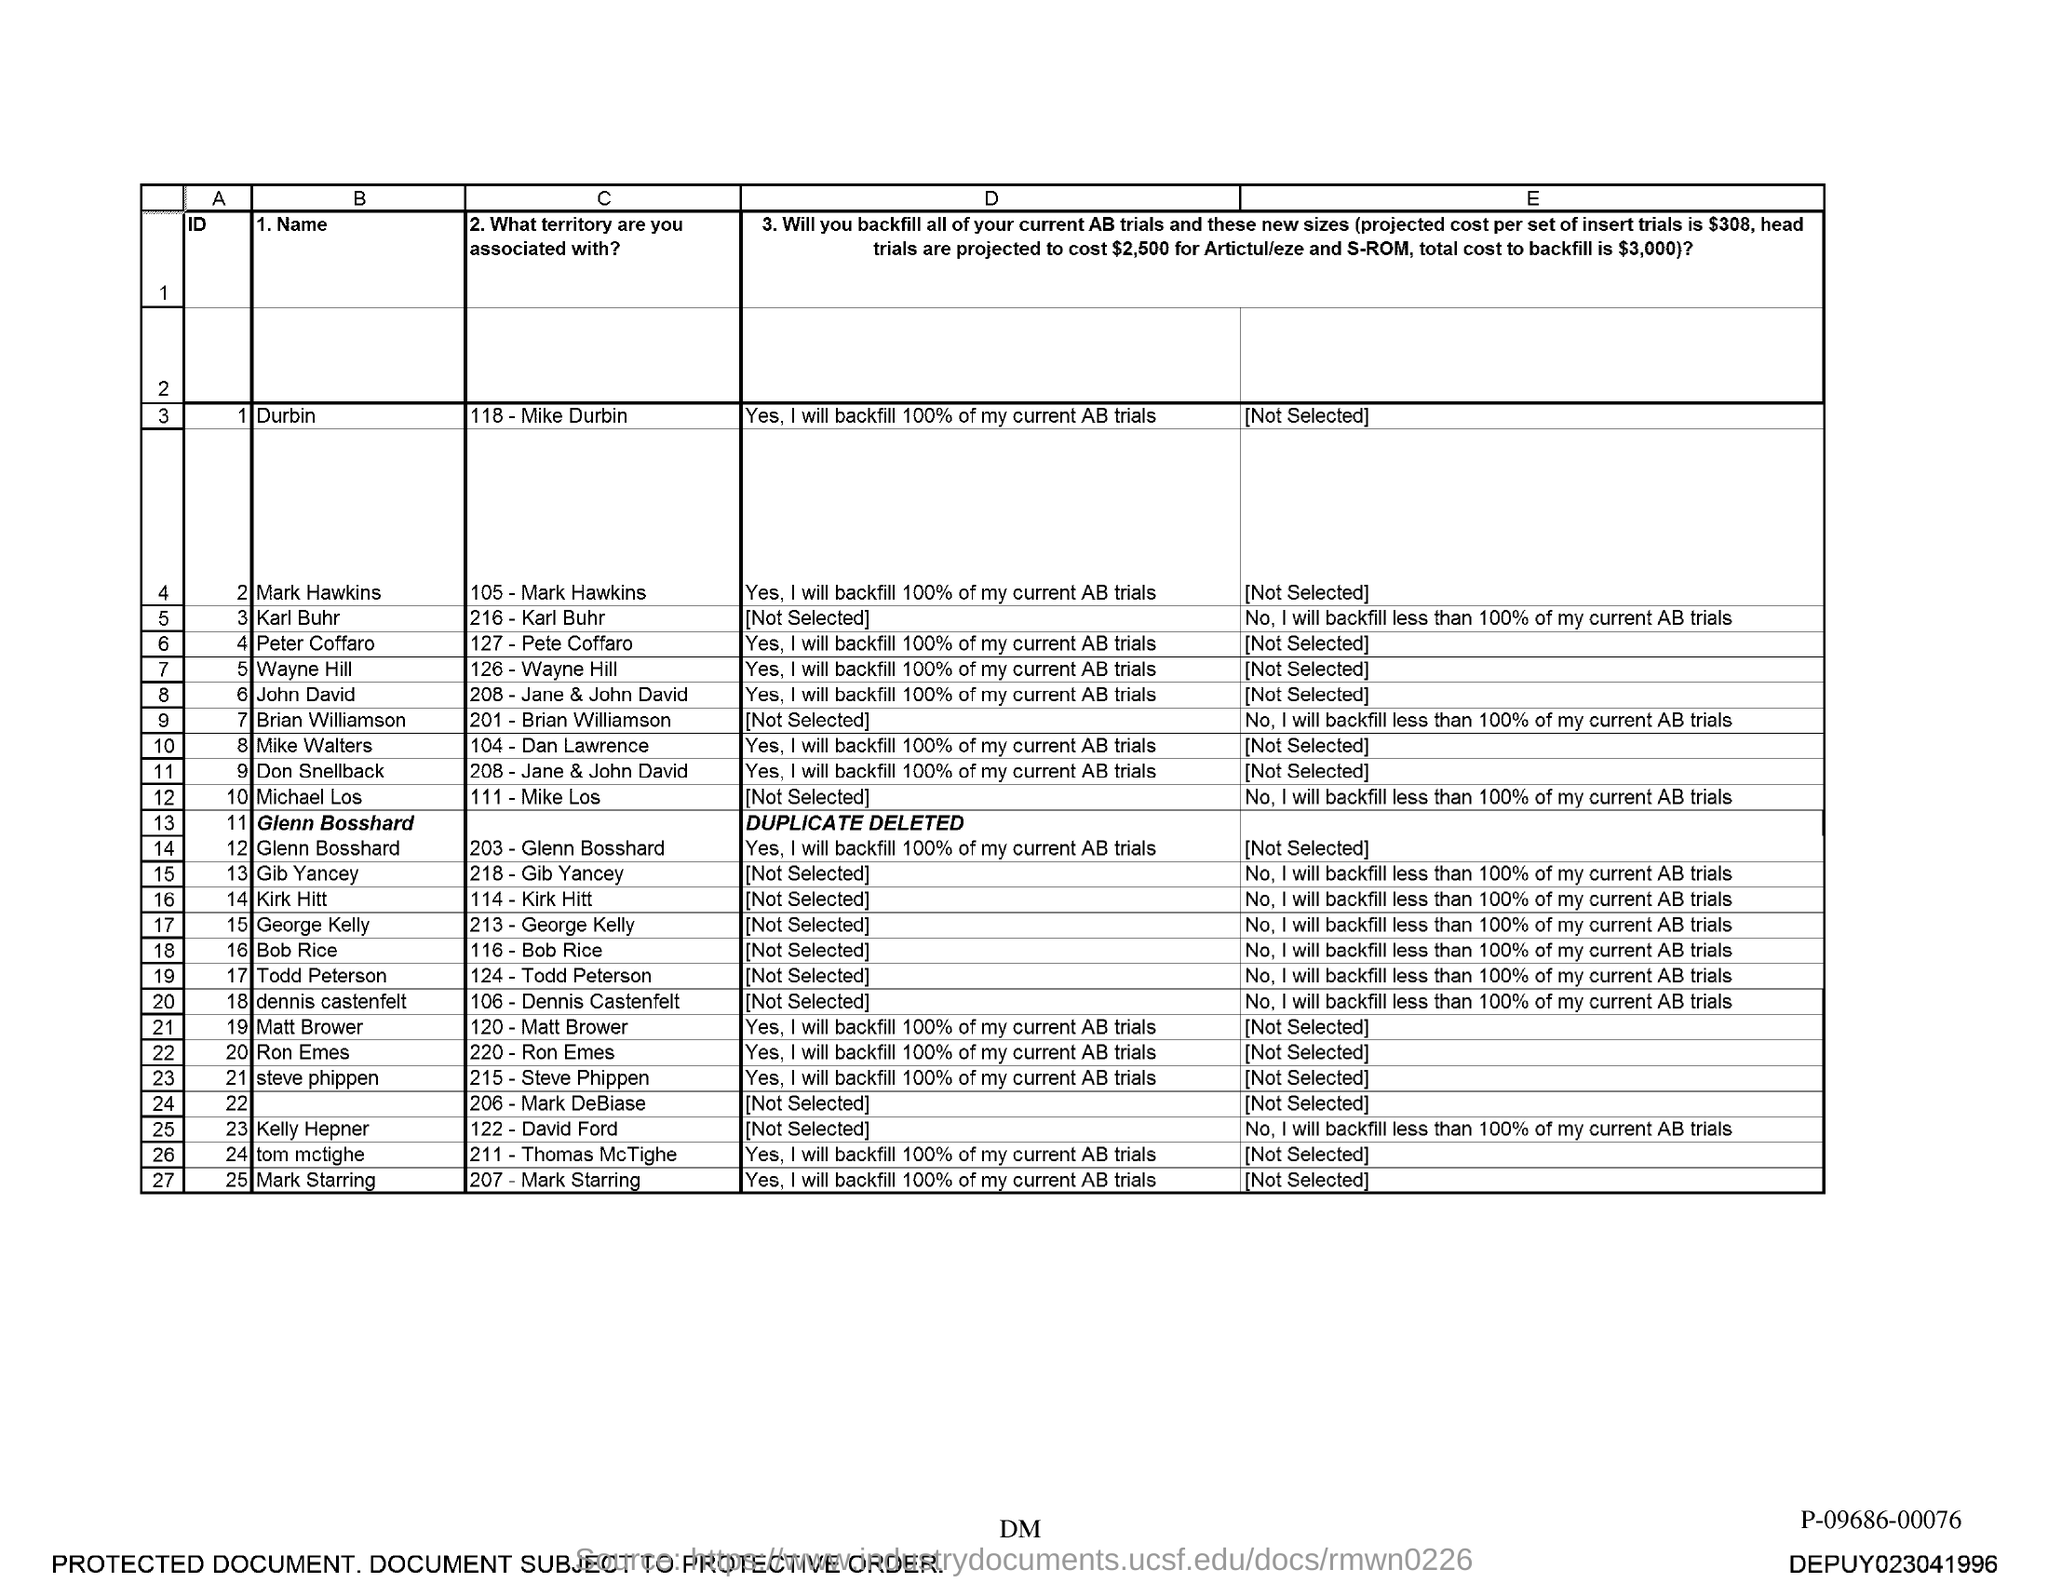Outline some significant characteristics in this image. The name associated with the ID 1 is Durbin. 